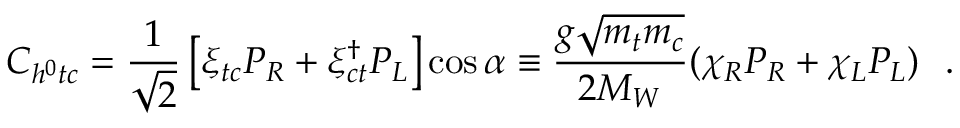<formula> <loc_0><loc_0><loc_500><loc_500>C _ { h ^ { 0 } t c } = \frac { 1 } { \sqrt { 2 } } \left [ \xi _ { t c } P _ { R } + \xi _ { c t } ^ { \dagger } P _ { L } \right ] \cos \alpha \equiv \frac { g \sqrt { m _ { t } m _ { c } } } { 2 M _ { W } } ( \chi _ { R } P _ { R } + \chi _ { L } P _ { L } ) \, .</formula> 